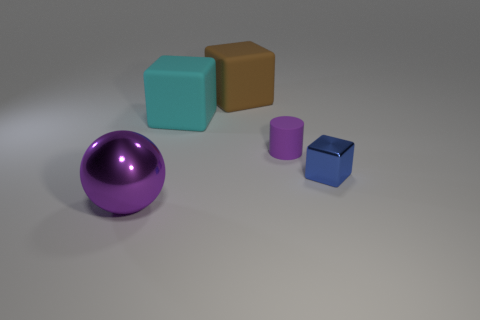What number of purple matte cylinders are left of the big brown block?
Provide a succinct answer. 0. Does the large ball have the same color as the small matte cylinder?
Give a very brief answer. Yes. What is the shape of the object that is made of the same material as the small block?
Provide a short and direct response. Sphere. There is a purple object behind the metal sphere; is its shape the same as the large purple metal object?
Your answer should be compact. No. What number of yellow objects are shiny things or cylinders?
Make the answer very short. 0. Are there an equal number of brown shiny things and small things?
Your answer should be compact. No. Are there the same number of metal cubes that are in front of the small blue metal cube and rubber things that are to the left of the brown object?
Your answer should be compact. No. The metal thing left of the purple object that is behind the large thing that is in front of the purple matte object is what color?
Your answer should be very brief. Purple. Is there anything else of the same color as the large ball?
Keep it short and to the point. Yes. There is a tiny matte object that is the same color as the large shiny object; what shape is it?
Offer a terse response. Cylinder. 